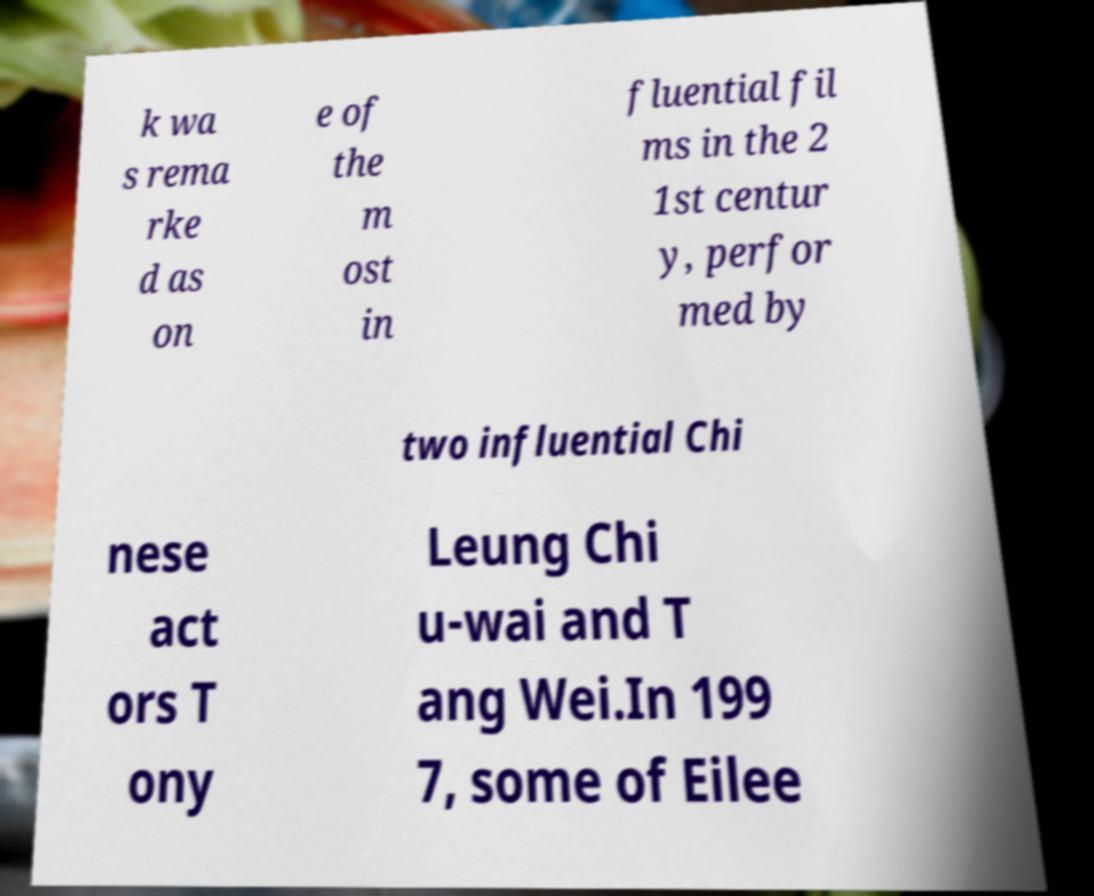Please read and relay the text visible in this image. What does it say? k wa s rema rke d as on e of the m ost in fluential fil ms in the 2 1st centur y, perfor med by two influential Chi nese act ors T ony Leung Chi u-wai and T ang Wei.In 199 7, some of Eilee 